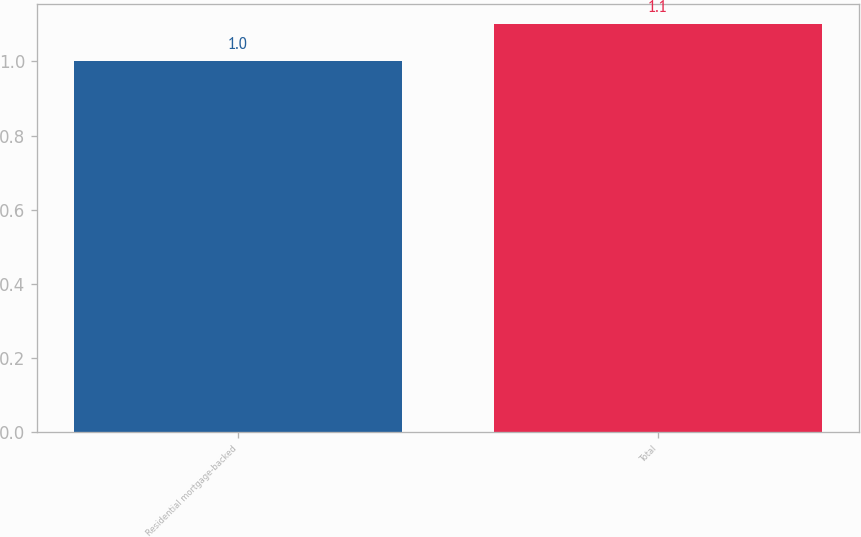Convert chart. <chart><loc_0><loc_0><loc_500><loc_500><bar_chart><fcel>Residential mortgage-backed<fcel>Total<nl><fcel>1<fcel>1.1<nl></chart> 